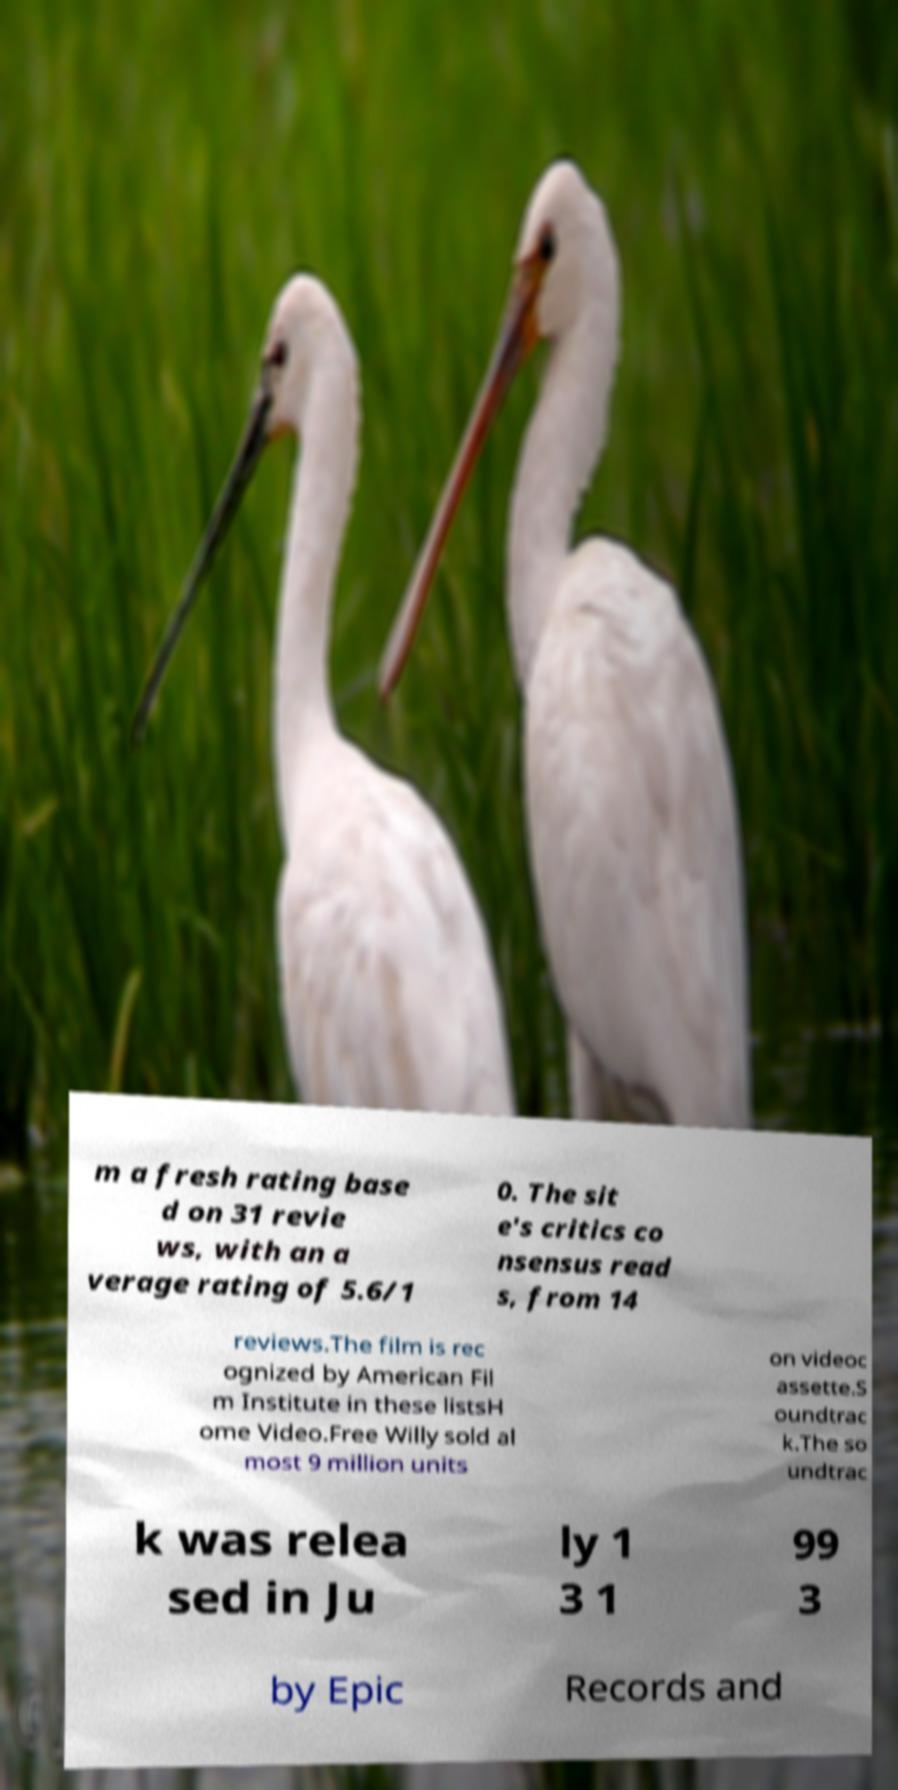Could you assist in decoding the text presented in this image and type it out clearly? m a fresh rating base d on 31 revie ws, with an a verage rating of 5.6/1 0. The sit e's critics co nsensus read s, from 14 reviews.The film is rec ognized by American Fil m Institute in these listsH ome Video.Free Willy sold al most 9 million units on videoc assette.S oundtrac k.The so undtrac k was relea sed in Ju ly 1 3 1 99 3 by Epic Records and 